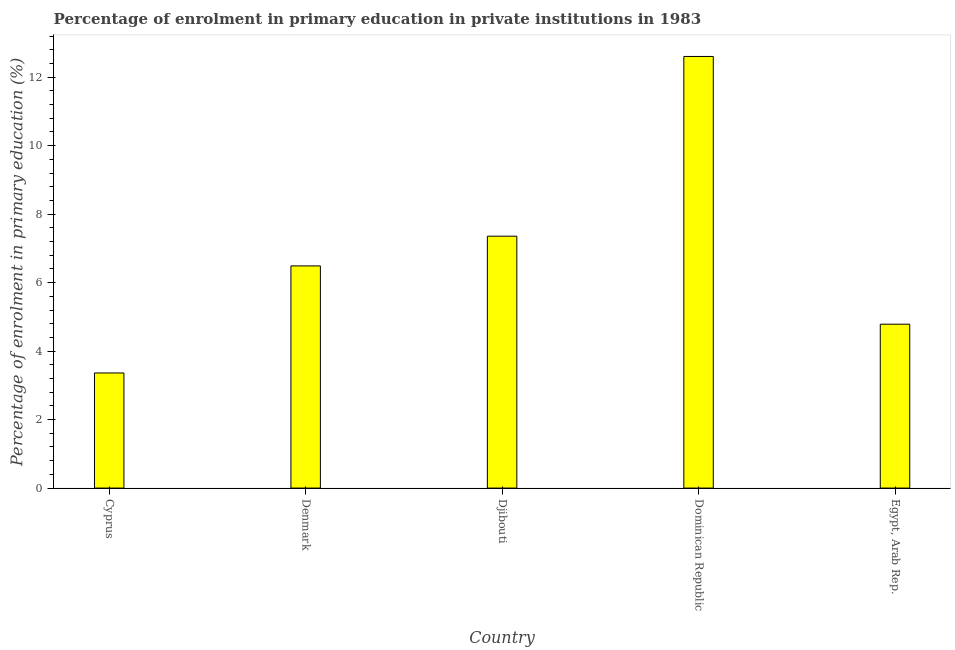Does the graph contain any zero values?
Provide a short and direct response. No. Does the graph contain grids?
Your answer should be compact. No. What is the title of the graph?
Keep it short and to the point. Percentage of enrolment in primary education in private institutions in 1983. What is the label or title of the X-axis?
Give a very brief answer. Country. What is the label or title of the Y-axis?
Provide a succinct answer. Percentage of enrolment in primary education (%). What is the enrolment percentage in primary education in Egypt, Arab Rep.?
Make the answer very short. 4.79. Across all countries, what is the maximum enrolment percentage in primary education?
Provide a succinct answer. 12.6. Across all countries, what is the minimum enrolment percentage in primary education?
Your answer should be compact. 3.36. In which country was the enrolment percentage in primary education maximum?
Ensure brevity in your answer.  Dominican Republic. In which country was the enrolment percentage in primary education minimum?
Provide a short and direct response. Cyprus. What is the sum of the enrolment percentage in primary education?
Provide a succinct answer. 34.59. What is the difference between the enrolment percentage in primary education in Cyprus and Dominican Republic?
Provide a short and direct response. -9.24. What is the average enrolment percentage in primary education per country?
Give a very brief answer. 6.92. What is the median enrolment percentage in primary education?
Make the answer very short. 6.49. What is the ratio of the enrolment percentage in primary education in Cyprus to that in Dominican Republic?
Ensure brevity in your answer.  0.27. What is the difference between the highest and the second highest enrolment percentage in primary education?
Your answer should be very brief. 5.25. What is the difference between the highest and the lowest enrolment percentage in primary education?
Provide a short and direct response. 9.24. What is the difference between two consecutive major ticks on the Y-axis?
Your answer should be very brief. 2. Are the values on the major ticks of Y-axis written in scientific E-notation?
Give a very brief answer. No. What is the Percentage of enrolment in primary education (%) in Cyprus?
Ensure brevity in your answer.  3.36. What is the Percentage of enrolment in primary education (%) of Denmark?
Offer a terse response. 6.49. What is the Percentage of enrolment in primary education (%) in Djibouti?
Offer a terse response. 7.36. What is the Percentage of enrolment in primary education (%) of Dominican Republic?
Your answer should be very brief. 12.6. What is the Percentage of enrolment in primary education (%) in Egypt, Arab Rep.?
Provide a succinct answer. 4.79. What is the difference between the Percentage of enrolment in primary education (%) in Cyprus and Denmark?
Keep it short and to the point. -3.13. What is the difference between the Percentage of enrolment in primary education (%) in Cyprus and Djibouti?
Your answer should be compact. -3.99. What is the difference between the Percentage of enrolment in primary education (%) in Cyprus and Dominican Republic?
Provide a short and direct response. -9.24. What is the difference between the Percentage of enrolment in primary education (%) in Cyprus and Egypt, Arab Rep.?
Keep it short and to the point. -1.42. What is the difference between the Percentage of enrolment in primary education (%) in Denmark and Djibouti?
Your answer should be compact. -0.87. What is the difference between the Percentage of enrolment in primary education (%) in Denmark and Dominican Republic?
Your answer should be very brief. -6.12. What is the difference between the Percentage of enrolment in primary education (%) in Denmark and Egypt, Arab Rep.?
Keep it short and to the point. 1.7. What is the difference between the Percentage of enrolment in primary education (%) in Djibouti and Dominican Republic?
Provide a short and direct response. -5.25. What is the difference between the Percentage of enrolment in primary education (%) in Djibouti and Egypt, Arab Rep.?
Your response must be concise. 2.57. What is the difference between the Percentage of enrolment in primary education (%) in Dominican Republic and Egypt, Arab Rep.?
Your answer should be very brief. 7.82. What is the ratio of the Percentage of enrolment in primary education (%) in Cyprus to that in Denmark?
Give a very brief answer. 0.52. What is the ratio of the Percentage of enrolment in primary education (%) in Cyprus to that in Djibouti?
Your answer should be compact. 0.46. What is the ratio of the Percentage of enrolment in primary education (%) in Cyprus to that in Dominican Republic?
Give a very brief answer. 0.27. What is the ratio of the Percentage of enrolment in primary education (%) in Cyprus to that in Egypt, Arab Rep.?
Your answer should be very brief. 0.7. What is the ratio of the Percentage of enrolment in primary education (%) in Denmark to that in Djibouti?
Your response must be concise. 0.88. What is the ratio of the Percentage of enrolment in primary education (%) in Denmark to that in Dominican Republic?
Offer a terse response. 0.52. What is the ratio of the Percentage of enrolment in primary education (%) in Denmark to that in Egypt, Arab Rep.?
Keep it short and to the point. 1.36. What is the ratio of the Percentage of enrolment in primary education (%) in Djibouti to that in Dominican Republic?
Keep it short and to the point. 0.58. What is the ratio of the Percentage of enrolment in primary education (%) in Djibouti to that in Egypt, Arab Rep.?
Provide a short and direct response. 1.54. What is the ratio of the Percentage of enrolment in primary education (%) in Dominican Republic to that in Egypt, Arab Rep.?
Provide a short and direct response. 2.63. 